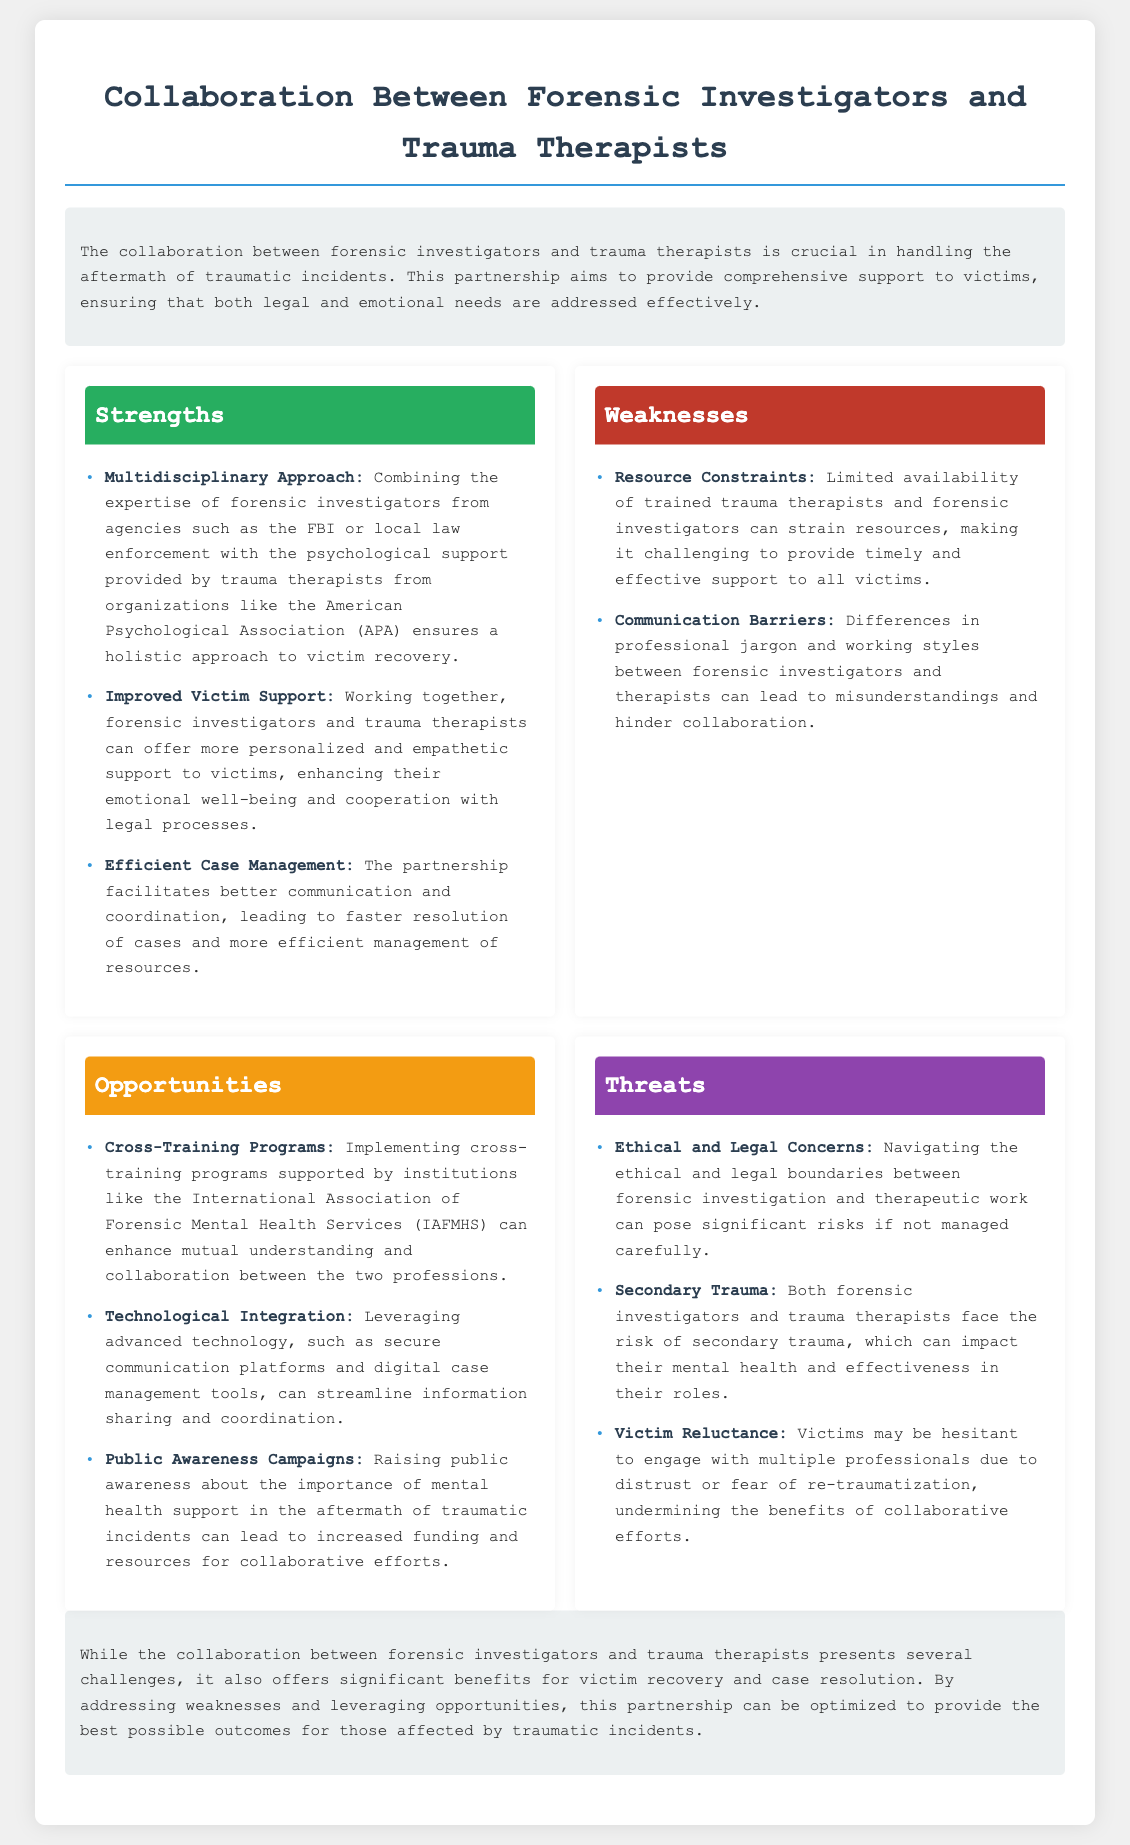What is the title of the document? The title of the document is mentioned in the header section which describes the analysis context, specifically aimed at collaboration between two professional fields.
Answer: Collaboration Between Forensic Investigators and Trauma Therapists Who are the primary professionals involved in this collaboration? The primary professionals mentioned in the document who collaborate are forensic investigators and trauma therapists.
Answer: Forensic investigators and trauma therapists What is one strength of the collaboration? One strength is highlighted in the strengths section focusing on the combined knowledge and skills which lead to a better outcome for victims.
Answer: Multidisciplinary Approach What is a weakness related to communication? A specific weakness identified relates to different professional languages and styles that could affect their interactions and cooperation.
Answer: Communication Barriers What opportunity involves training programs? An opportunity addressing cross-training indicates a possible enhancement in collaboration through educational initiatives designed for both professions.
Answer: Cross-Training Programs What is one potential threat faced by the professionals? One of the threats highlighted is the risk that can affect both professions due to their exposure to traumatic experiences over time.
Answer: Secondary Trauma What is mentioned as a way to raise awareness? The document outlines public engagement initiatives to inform communities about the importance of mental health support following traumatic events.
Answer: Public Awareness Campaigns 